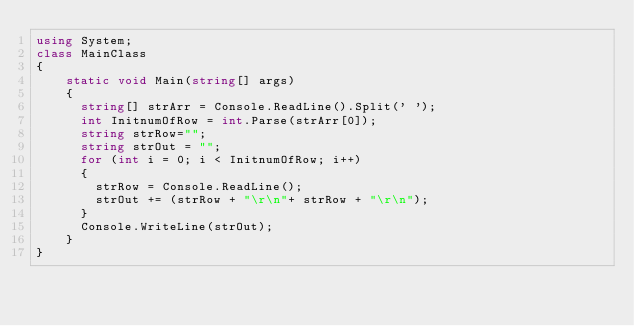<code> <loc_0><loc_0><loc_500><loc_500><_C#_>using System;
class MainClass
{
	static void Main(string[] args)
	{
      string[] strArr = Console.ReadLine().Split(' ');
      int InitnumOfRow = int.Parse(strArr[0]);
      string strRow="";
      string strOut = "";
      for (int i = 0; i < InitnumOfRow; i++)
      {
        strRow = Console.ReadLine();
        strOut += (strRow + "\r\n"+ strRow + "\r\n");
      }
      Console.WriteLine(strOut);
	}
}</code> 